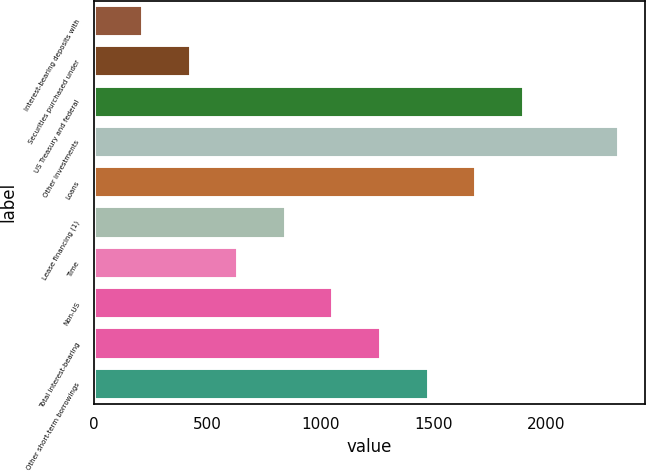Convert chart to OTSL. <chart><loc_0><loc_0><loc_500><loc_500><bar_chart><fcel>Interest-bearing deposits with<fcel>Securities purchased under<fcel>US Treasury and federal<fcel>Other investments<fcel>Loans<fcel>Lease financing (1)<fcel>Time<fcel>Non-US<fcel>Total interest-bearing<fcel>Other short-term borrowings<nl><fcel>217.2<fcel>427.4<fcel>1898.8<fcel>2319.2<fcel>1688.6<fcel>847.8<fcel>637.6<fcel>1058<fcel>1268.2<fcel>1478.4<nl></chart> 